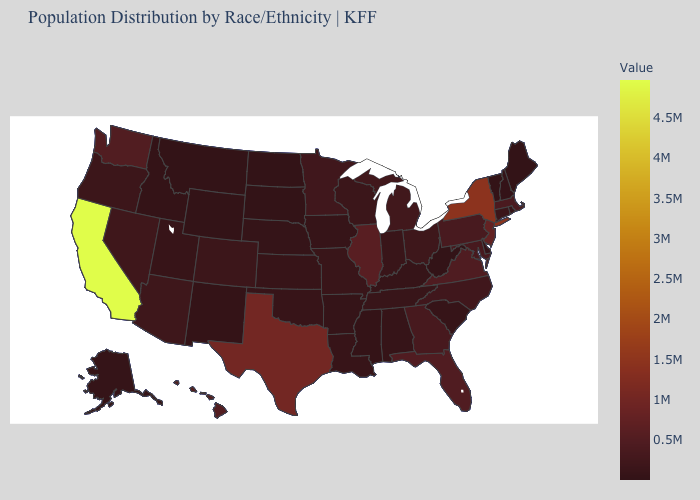Does the map have missing data?
Answer briefly. No. Which states have the highest value in the USA?
Keep it brief. California. Among the states that border Indiana , does Ohio have the lowest value?
Concise answer only. No. Does California have the highest value in the West?
Short answer required. Yes. Which states have the lowest value in the USA?
Be succinct. Wyoming. Which states hav the highest value in the South?
Write a very short answer. Texas. Does Texas have the highest value in the South?
Short answer required. Yes. 